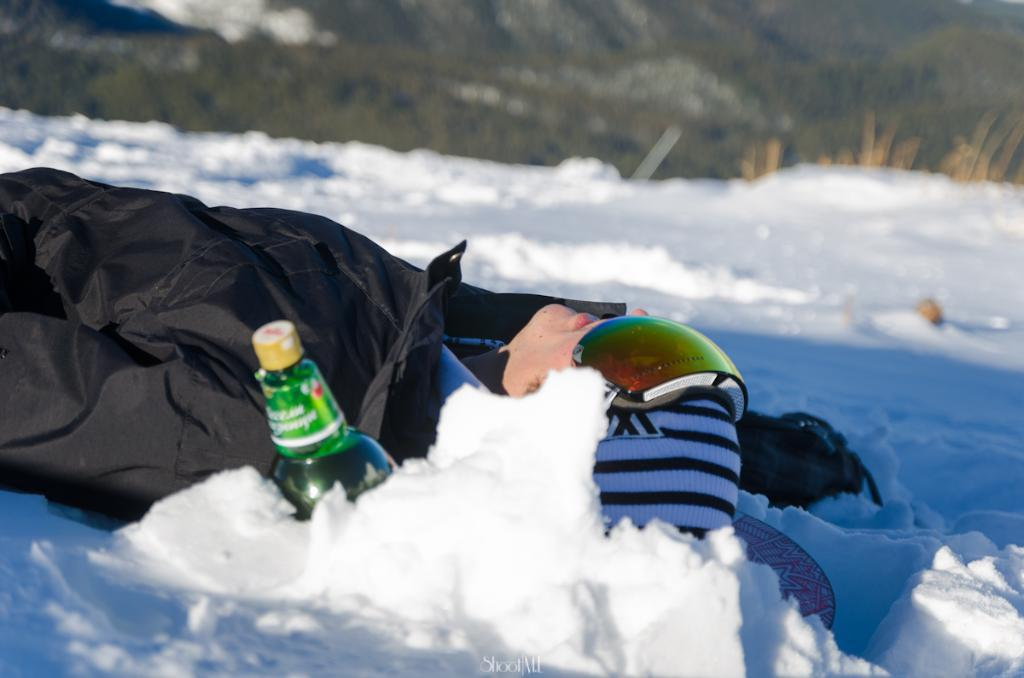What is the position of the man in the image? There is a man lying on the ground in the image. What is covering the ground in the image? There is snow on the ground. What object is in front of the man? There is a bottle in front of the man. What type of vegetation can be seen at the top of the image? There are plants visible at the top of the image. What type of coal is being exchanged between the man and the porter in the image? There is no mention of coal, a man, or a porter in the image. The image only features a man lying on the ground, snow on the ground, a bottle in front of the man, and plants visible at the top of the image. 